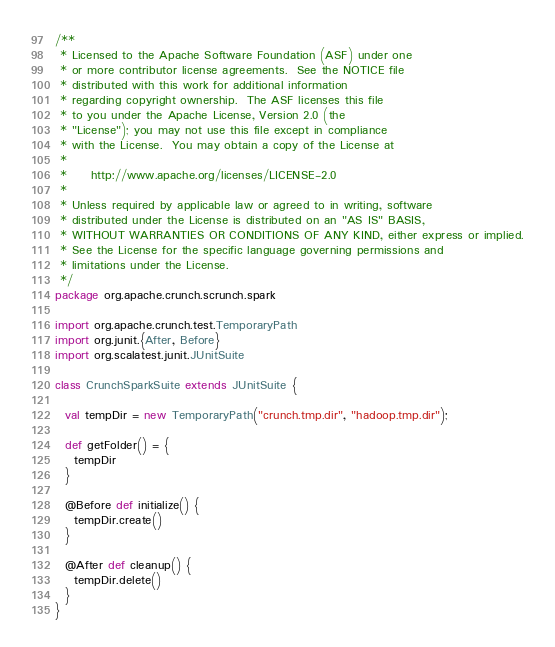Convert code to text. <code><loc_0><loc_0><loc_500><loc_500><_Scala_>/**
 * Licensed to the Apache Software Foundation (ASF) under one
 * or more contributor license agreements.  See the NOTICE file
 * distributed with this work for additional information
 * regarding copyright ownership.  The ASF licenses this file
 * to you under the Apache License, Version 2.0 (the
 * "License"); you may not use this file except in compliance
 * with the License.  You may obtain a copy of the License at
 *
 *     http://www.apache.org/licenses/LICENSE-2.0
 *
 * Unless required by applicable law or agreed to in writing, software
 * distributed under the License is distributed on an "AS IS" BASIS,
 * WITHOUT WARRANTIES OR CONDITIONS OF ANY KIND, either express or implied.
 * See the License for the specific language governing permissions and
 * limitations under the License.
 */
package org.apache.crunch.scrunch.spark

import org.apache.crunch.test.TemporaryPath
import org.junit.{After, Before}
import org.scalatest.junit.JUnitSuite

class CrunchSparkSuite extends JUnitSuite {

  val tempDir = new TemporaryPath("crunch.tmp.dir", "hadoop.tmp.dir");

  def getFolder() = {
    tempDir
  }

  @Before def initialize() {
    tempDir.create()
  }

  @After def cleanup() {
    tempDir.delete()
  }
}
</code> 